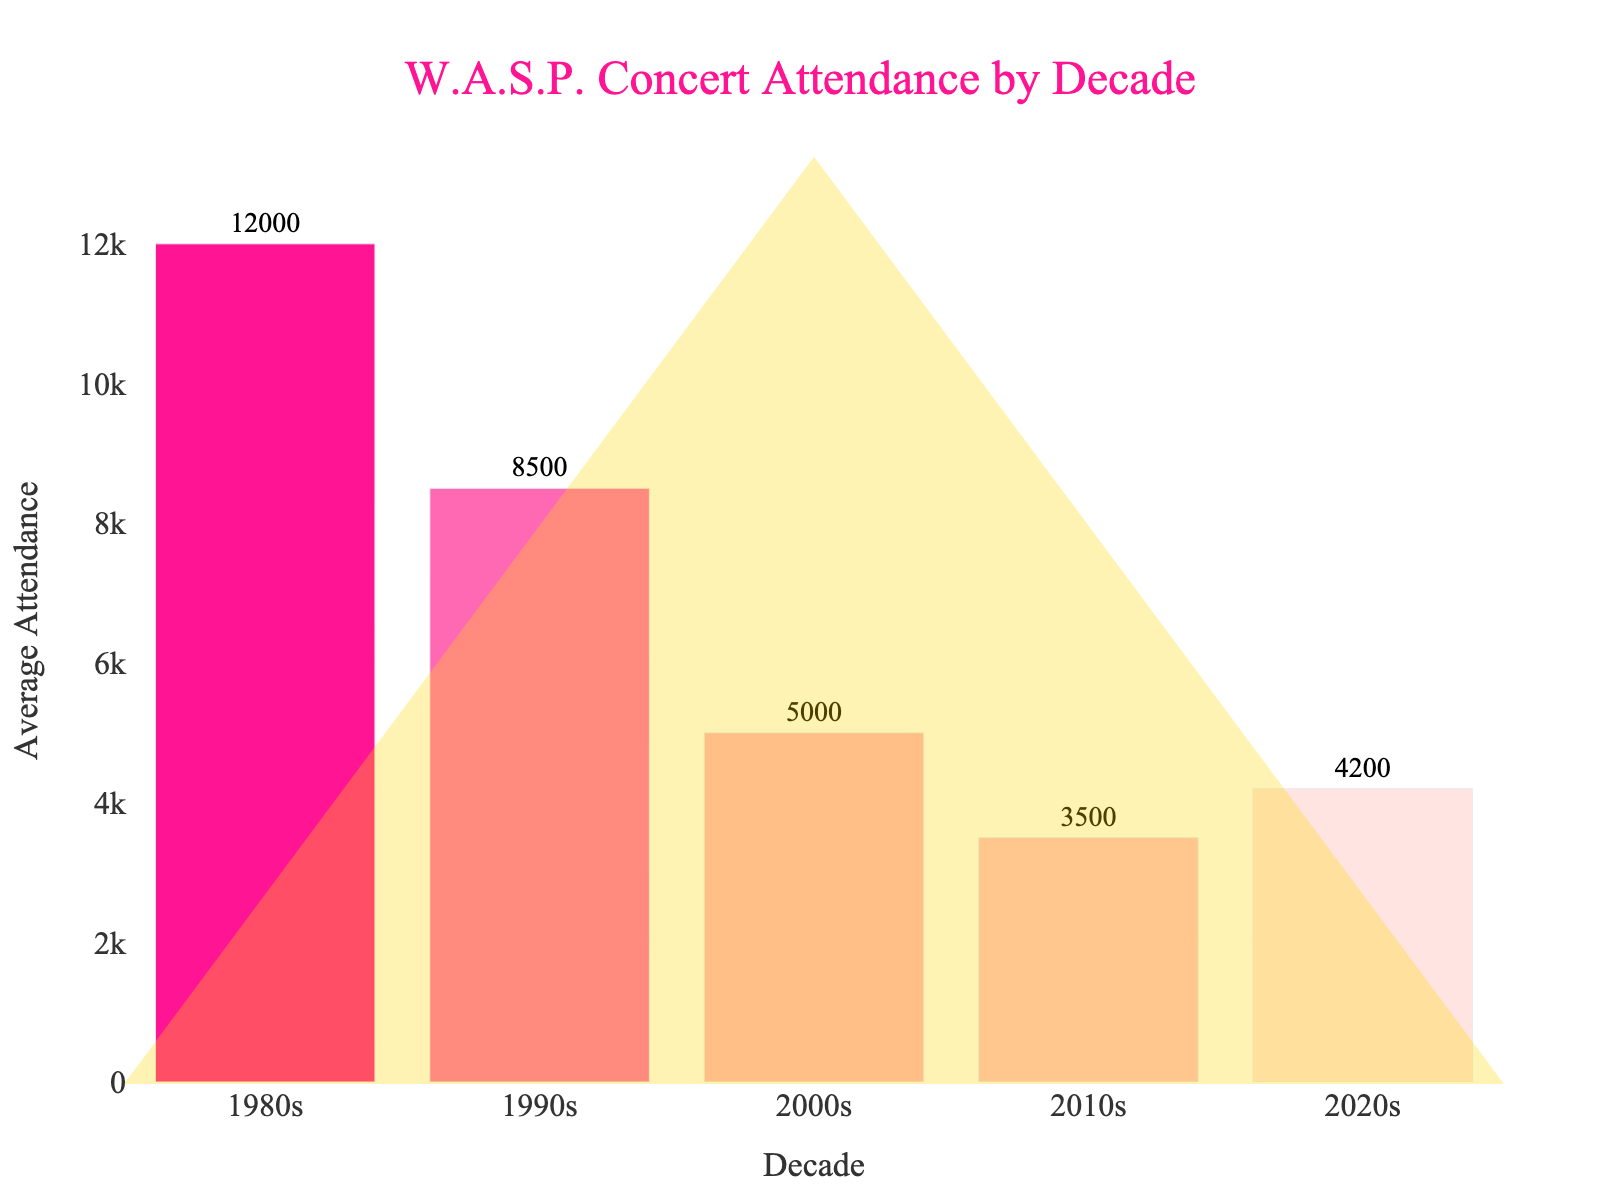How has W.A.S.P.'s concert attendance trended from the 1980s to the 2020s? The figure shows a decreasing trend in average concert attendance for each subsequent decade from the 1980s through the 2010s, with a slight increase in the 2020s. In the 1980s, the average attendance was 12000, dropping to 8500 in the 1990s, then to 5000 in the 2000s, further decreasing to 3500 in the 2010s, before slightly rising to 4200 in the 2020s.
Answer: Decreasing, then slightly increasing in the 2020s Which decade had the highest average concert attendance for W.A.S.P. tours? The figure's bar height indicates that the 1980s had the highest average concert attendance at 12000. This is the tallest bar on the chart.
Answer: 1980s What is the difference in average concert attendance between the 1980s and the 1990s? Subtract the average attendance in the 1990s (8500) from the average attendance in the 1980s (12000). 12000 - 8500 = 3500.
Answer: 3500 How does the average concert attendance in the 2020s compare to the 2010s? The height of the bars shows that the average attendance in the 2020s (4200) is slightly higher than in the 2010s (3500).
Answer: Greater in the 2020s Calculate the average concert attendance across all decades. Add the attendance for all decades (12000 + 8500 + 5000 + 3500 + 4200) and divide by the number of decades (5). The total is 33200, and 33200 / 5 = 6640.
Answer: 6640 Which decade experienced the largest decrease in average concert attendance compared to its preceding decade? Calculate the differences: 1990s (8500) - 1980s (12000) = -3500; 2000s (5000) - 1990s (8500) = -3500; 2010s (3500) - 2000s (5000) = -1500; 2020s (4200) - 2010s (3500) = +700. The 1990s and the 2000s both experienced the largest decrease of 3500.
Answer: 1990s and 2000s Compare the average attendances of the 1980s and 2010s. How much higher was the attendance in the 1980s? Subtract the average attendance in the 2010s (3500) from the 1980s (12000). The difference is 12000 - 3500 = 8500.
Answer: 8500 higher What percentage increase in average attendance is seen from the 2010s to the 2020s? Calculate the difference: 4200 (2020s) - 3500 (2010s) = 700. Then divide by the 2010s attendance: 700 / 3500 = 0.2. Convert to percentage: 0.2 * 100 = 20%.
Answer: 20% Which decade has the least average concert attendance, and what is its value? The shortest bar represents the 2010s with an average attendance of 3500.
Answer: 2010s, 3500 